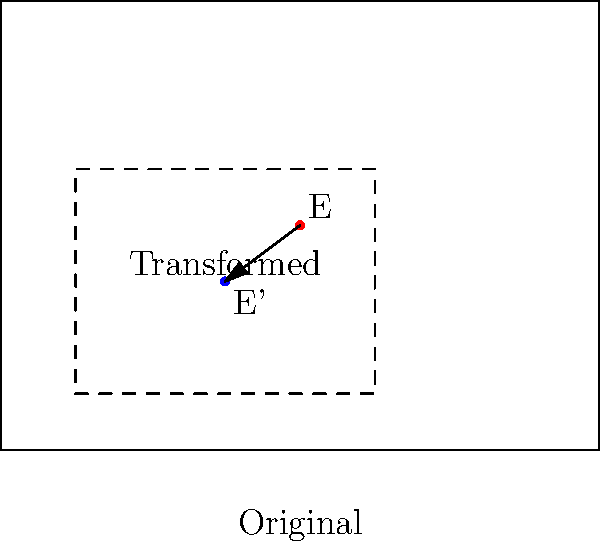In a cargo loading optimization process, a rectangular loading area ABCD is transformed to maximize efficiency. The transformation applied is a composition of scaling by a factor of 0.5 followed by a translation of (1, 0.75) units. If point E(2, 1.5) represents a crucial loading point in the original configuration, what are the coordinates of E' (the transformed point E) in the new configuration? To find the coordinates of E' after the composite transformation, we need to follow these steps:

1) First, apply the scaling transformation:
   Scaling by 0.5 means multiplying both x and y coordinates by 0.5.
   $E(2, 1.5) \rightarrow (2 * 0.5, 1.5 * 0.5) = (1, 0.75)$

2) Then, apply the translation:
   Translation by (1, 0.75) means adding 1 to x-coordinate and 0.75 to y-coordinate.
   $(1, 0.75) \rightarrow (1 + 1, 0.75 + 0.75) = (2, 1.5)$

3) Therefore, the final coordinates of E' are (2, 1.5).

This transformation effectively reduces the size of the loading area while shifting its position, which could represent a more efficient use of space in the cargo hold.
Answer: $(2, 1.5)$ 